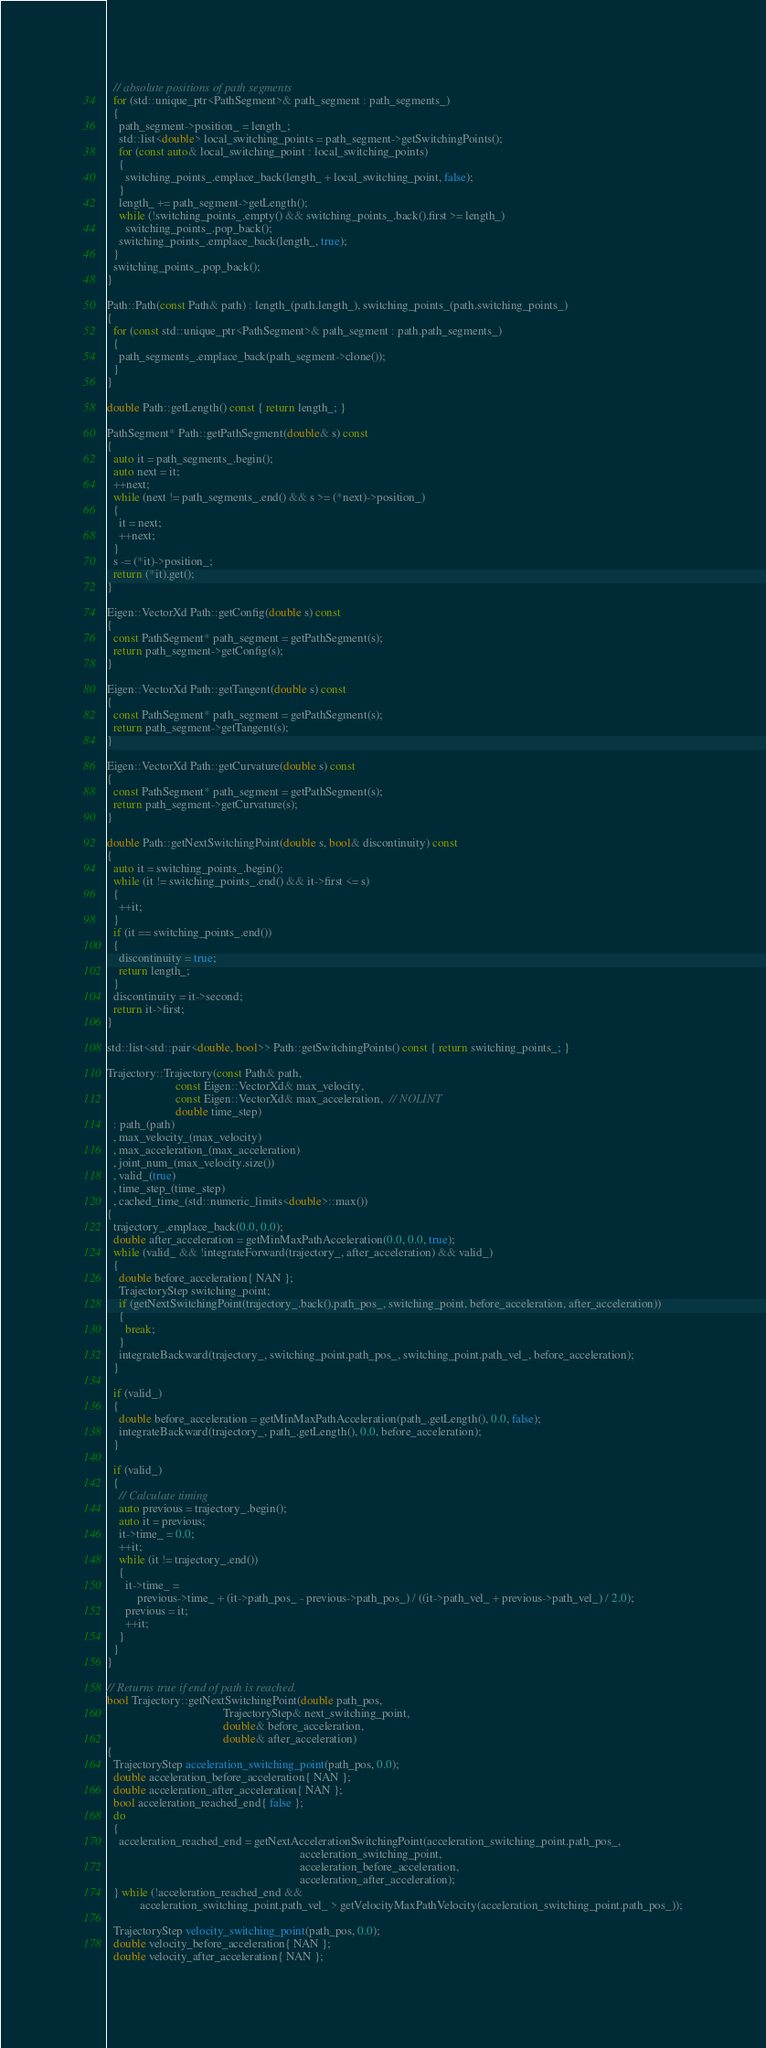<code> <loc_0><loc_0><loc_500><loc_500><_C++_>  // absolute positions of path segments
  for (std::unique_ptr<PathSegment>& path_segment : path_segments_)
  {
    path_segment->position_ = length_;
    std::list<double> local_switching_points = path_segment->getSwitchingPoints();
    for (const auto& local_switching_point : local_switching_points)
    {
      switching_points_.emplace_back(length_ + local_switching_point, false);
    }
    length_ += path_segment->getLength();
    while (!switching_points_.empty() && switching_points_.back().first >= length_)
      switching_points_.pop_back();
    switching_points_.emplace_back(length_, true);
  }
  switching_points_.pop_back();
}

Path::Path(const Path& path) : length_(path.length_), switching_points_(path.switching_points_)
{
  for (const std::unique_ptr<PathSegment>& path_segment : path.path_segments_)
  {
    path_segments_.emplace_back(path_segment->clone());
  }
}

double Path::getLength() const { return length_; }

PathSegment* Path::getPathSegment(double& s) const
{
  auto it = path_segments_.begin();
  auto next = it;
  ++next;
  while (next != path_segments_.end() && s >= (*next)->position_)
  {
    it = next;
    ++next;
  }
  s -= (*it)->position_;
  return (*it).get();
}

Eigen::VectorXd Path::getConfig(double s) const
{
  const PathSegment* path_segment = getPathSegment(s);
  return path_segment->getConfig(s);
}

Eigen::VectorXd Path::getTangent(double s) const
{
  const PathSegment* path_segment = getPathSegment(s);
  return path_segment->getTangent(s);
}

Eigen::VectorXd Path::getCurvature(double s) const
{
  const PathSegment* path_segment = getPathSegment(s);
  return path_segment->getCurvature(s);
}

double Path::getNextSwitchingPoint(double s, bool& discontinuity) const
{
  auto it = switching_points_.begin();
  while (it != switching_points_.end() && it->first <= s)
  {
    ++it;
  }
  if (it == switching_points_.end())
  {
    discontinuity = true;
    return length_;
  }
  discontinuity = it->second;
  return it->first;
}

std::list<std::pair<double, bool>> Path::getSwitchingPoints() const { return switching_points_; }

Trajectory::Trajectory(const Path& path,
                       const Eigen::VectorXd& max_velocity,
                       const Eigen::VectorXd& max_acceleration,  // NOLINT
                       double time_step)
  : path_(path)
  , max_velocity_(max_velocity)
  , max_acceleration_(max_acceleration)
  , joint_num_(max_velocity.size())
  , valid_(true)
  , time_step_(time_step)
  , cached_time_(std::numeric_limits<double>::max())
{
  trajectory_.emplace_back(0.0, 0.0);
  double after_acceleration = getMinMaxPathAcceleration(0.0, 0.0, true);
  while (valid_ && !integrateForward(trajectory_, after_acceleration) && valid_)
  {
    double before_acceleration{ NAN };
    TrajectoryStep switching_point;
    if (getNextSwitchingPoint(trajectory_.back().path_pos_, switching_point, before_acceleration, after_acceleration))
    {
      break;
    }
    integrateBackward(trajectory_, switching_point.path_pos_, switching_point.path_vel_, before_acceleration);
  }

  if (valid_)
  {
    double before_acceleration = getMinMaxPathAcceleration(path_.getLength(), 0.0, false);
    integrateBackward(trajectory_, path_.getLength(), 0.0, before_acceleration);
  }

  if (valid_)
  {
    // Calculate timing
    auto previous = trajectory_.begin();
    auto it = previous;
    it->time_ = 0.0;
    ++it;
    while (it != trajectory_.end())
    {
      it->time_ =
          previous->time_ + (it->path_pos_ - previous->path_pos_) / ((it->path_vel_ + previous->path_vel_) / 2.0);
      previous = it;
      ++it;
    }
  }
}

// Returns true if end of path is reached.
bool Trajectory::getNextSwitchingPoint(double path_pos,
                                       TrajectoryStep& next_switching_point,
                                       double& before_acceleration,
                                       double& after_acceleration)
{
  TrajectoryStep acceleration_switching_point(path_pos, 0.0);
  double acceleration_before_acceleration{ NAN };
  double acceleration_after_acceleration{ NAN };
  bool acceleration_reached_end{ false };
  do
  {
    acceleration_reached_end = getNextAccelerationSwitchingPoint(acceleration_switching_point.path_pos_,
                                                                 acceleration_switching_point,
                                                                 acceleration_before_acceleration,
                                                                 acceleration_after_acceleration);
  } while (!acceleration_reached_end &&
           acceleration_switching_point.path_vel_ > getVelocityMaxPathVelocity(acceleration_switching_point.path_pos_));

  TrajectoryStep velocity_switching_point(path_pos, 0.0);
  double velocity_before_acceleration{ NAN };
  double velocity_after_acceleration{ NAN };</code> 